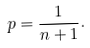Convert formula to latex. <formula><loc_0><loc_0><loc_500><loc_500>p = \frac { 1 } { n + 1 } .</formula> 